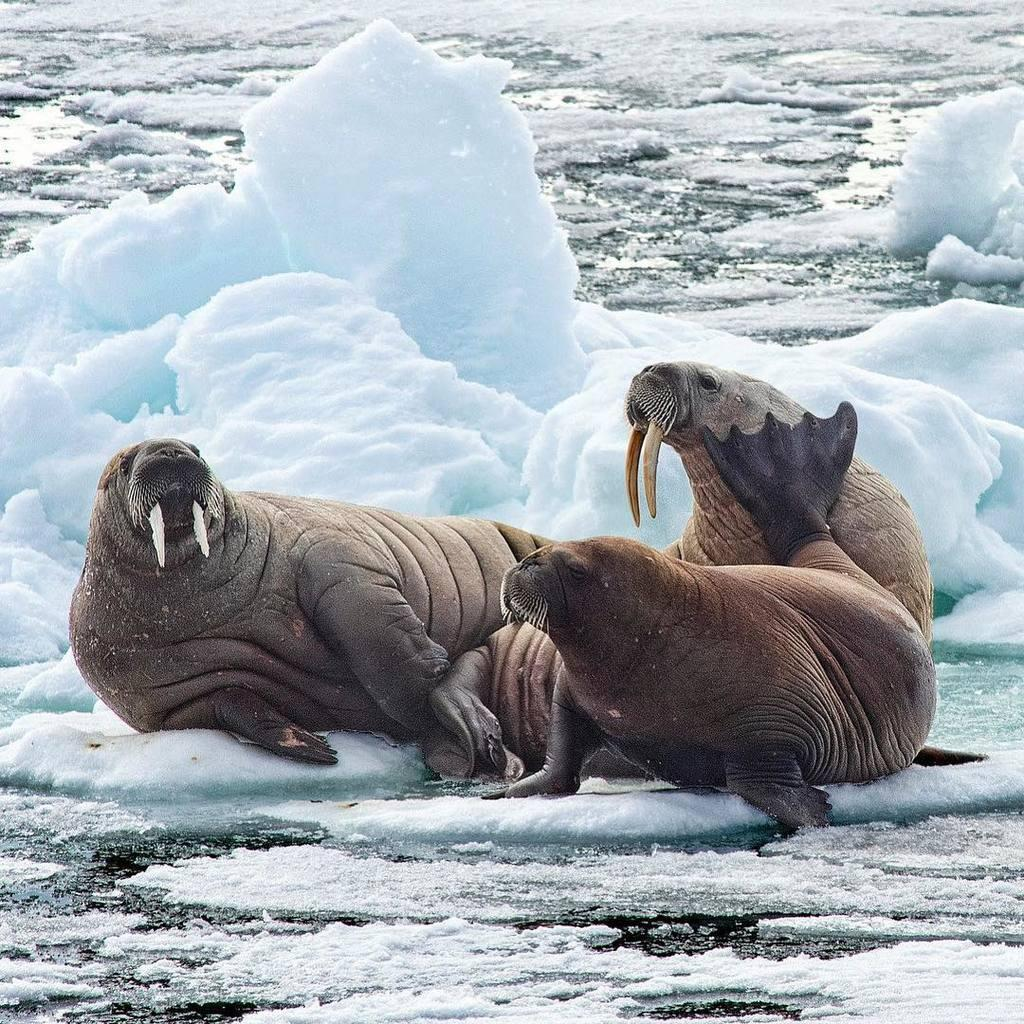What animals are located in the middle of the image? There are walruses in the middle of the image. What type of environment is depicted in the background of the image? There is ice in the background of the image. What is present at the bottom of the image? There is water at the bottom of the image. How are the ice and water related in the image? The ice is in contact with the water. What type of alarm can be heard going off in the image? There is no alarm present in the image, so it cannot be heard. How many walruses are seen smashing the ice in the image? There are no walruses smashing the ice in the image; they are simply located in the middle of the image. 